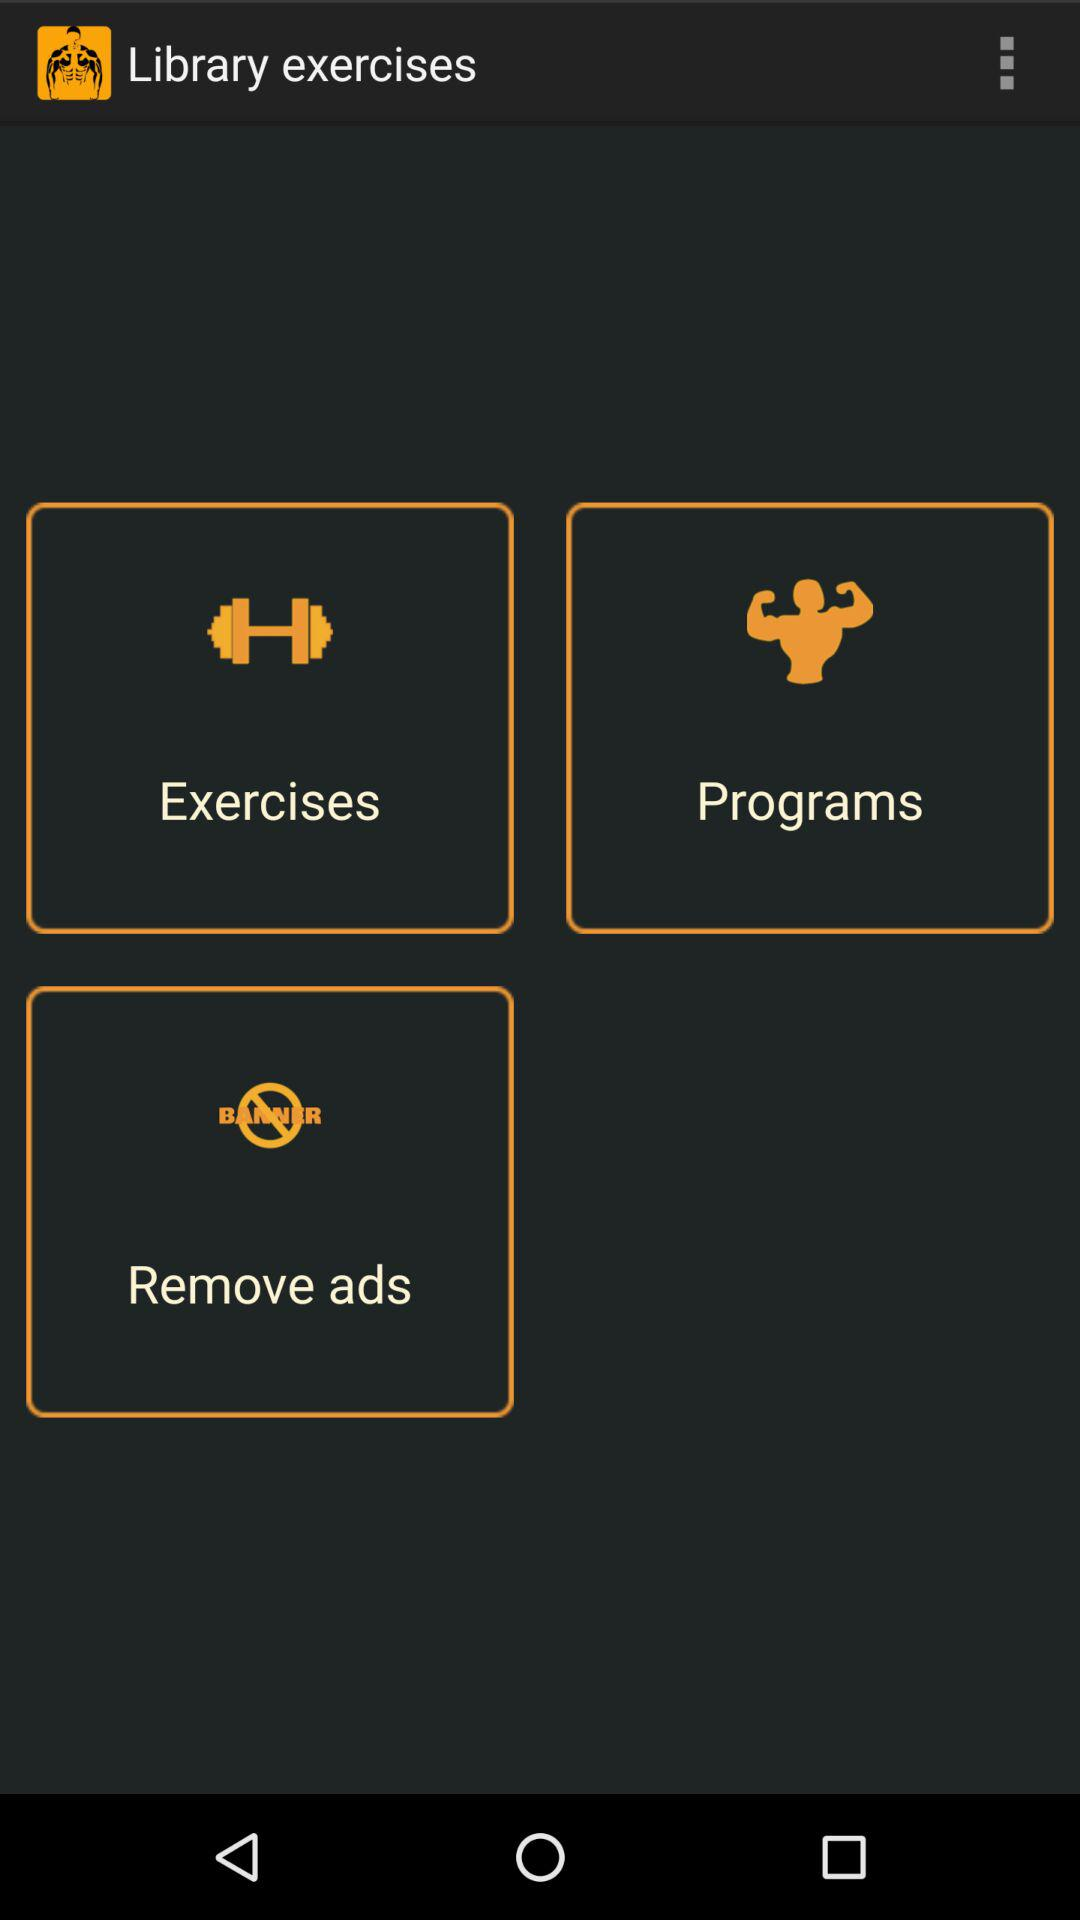What is the name of the application? The name of the application is "Library exercises". 